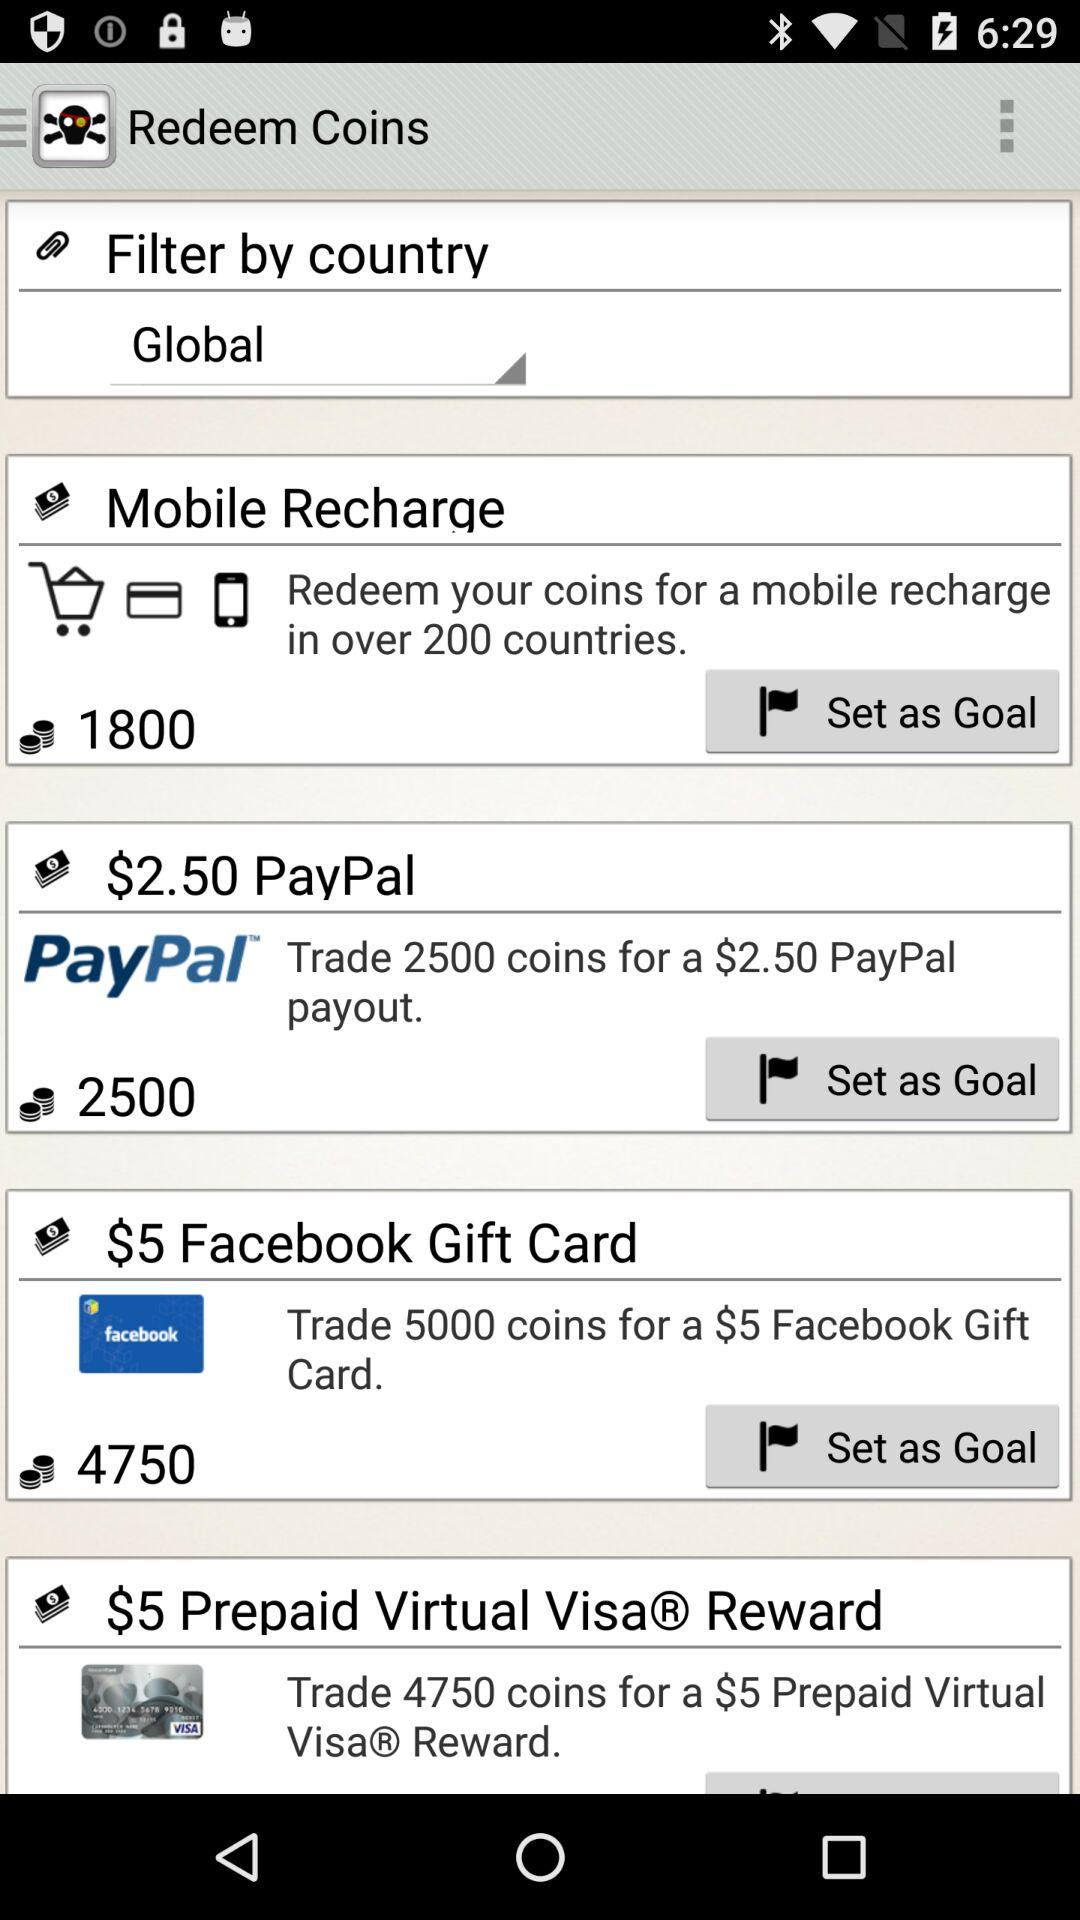For how many coins can we trade with PayPal? You can trade for 2500 coins. 